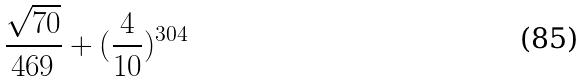<formula> <loc_0><loc_0><loc_500><loc_500>\frac { \sqrt { 7 0 } } { 4 6 9 } + ( \frac { 4 } { 1 0 } ) ^ { 3 0 4 }</formula> 